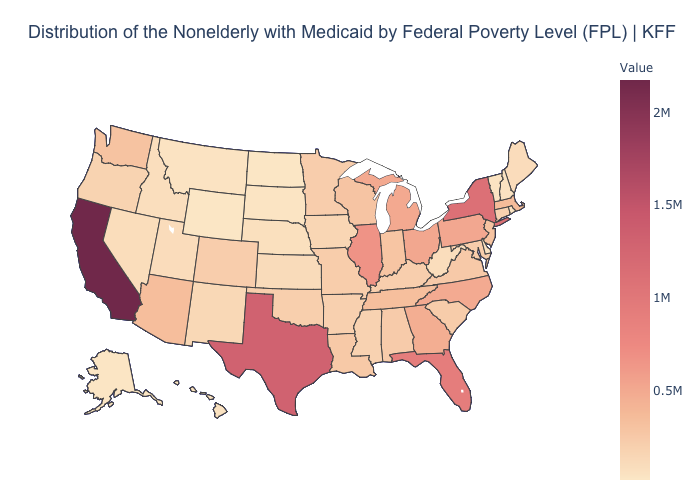Is the legend a continuous bar?
Concise answer only. Yes. Does Iowa have a higher value than Pennsylvania?
Short answer required. No. 